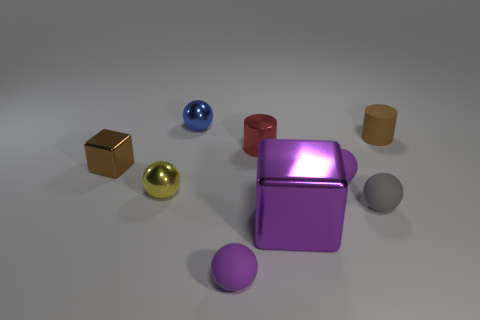Subtract all metal balls. How many balls are left? 3 Subtract all gray cylinders. How many purple spheres are left? 2 Subtract all yellow spheres. How many spheres are left? 4 Subtract all cylinders. How many objects are left? 7 Subtract 1 spheres. How many spheres are left? 4 Add 7 brown things. How many brown things are left? 9 Add 2 cyan metal cylinders. How many cyan metal cylinders exist? 2 Subtract 0 green cylinders. How many objects are left? 9 Subtract all green balls. Subtract all gray cylinders. How many balls are left? 5 Subtract all balls. Subtract all blue metal spheres. How many objects are left? 3 